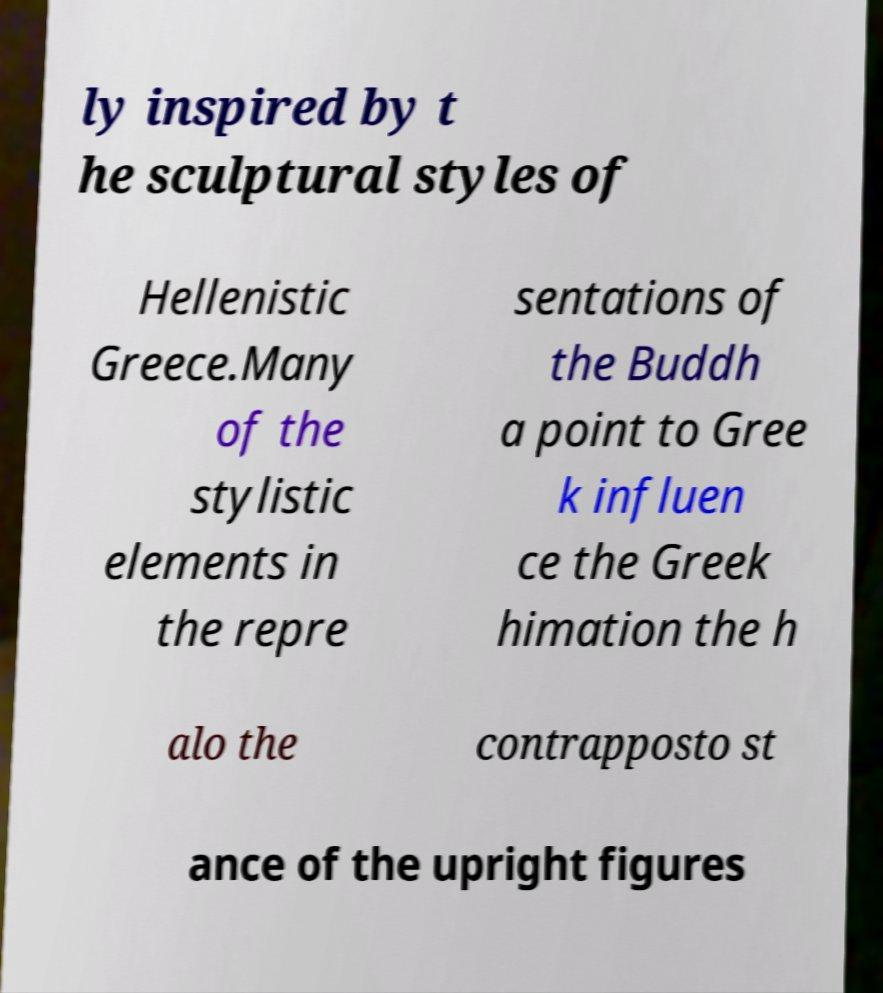Can you read and provide the text displayed in the image?This photo seems to have some interesting text. Can you extract and type it out for me? ly inspired by t he sculptural styles of Hellenistic Greece.Many of the stylistic elements in the repre sentations of the Buddh a point to Gree k influen ce the Greek himation the h alo the contrapposto st ance of the upright figures 